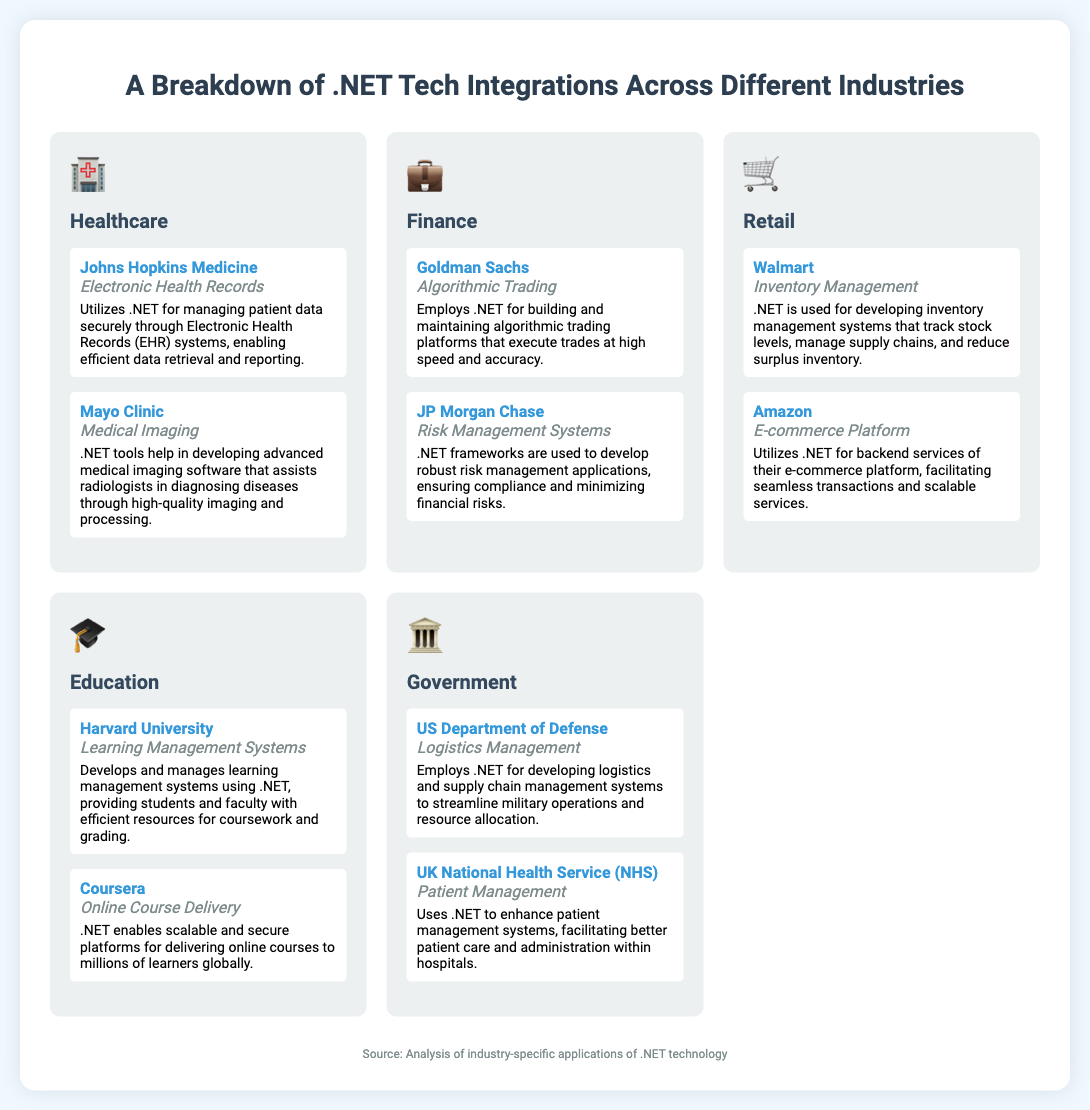What industry does Johns Hopkins Medicine belong to? Johns Hopkins Medicine is listed under the Healthcare industry section of the infographic.
Answer: Healthcare What integration system is used by Mayo Clinic? The infographic states that Mayo Clinic uses Medical Imaging as an integration system.
Answer: Medical Imaging Which finance company employs algorithmic trading? Goldman Sachs is identified in the infographic as employing algorithmic trading.
Answer: Goldman Sachs What integration is associated with Walmart in the retail industry? The infographic indicates that Walmart is associated with Inventory Management in the retail sector.
Answer: Inventory Management How many companies are listed under the Education section? There are two companies listed under the Education section, Harvard University and Coursera.
Answer: 2 What does the UK National Health Service (NHS) use .NET for? The NHS uses .NET for Patient Management, according to the document.
Answer: Patient Management In which industry is logistics management utilized? Logistics Management is utilized in the Government industry as per the infographic's information.
Answer: Government What is the primary focus of Coursera's use of .NET? Coursera's primary focus of using .NET is for Online Course Delivery, as listed in the document.
Answer: Online Course Delivery 